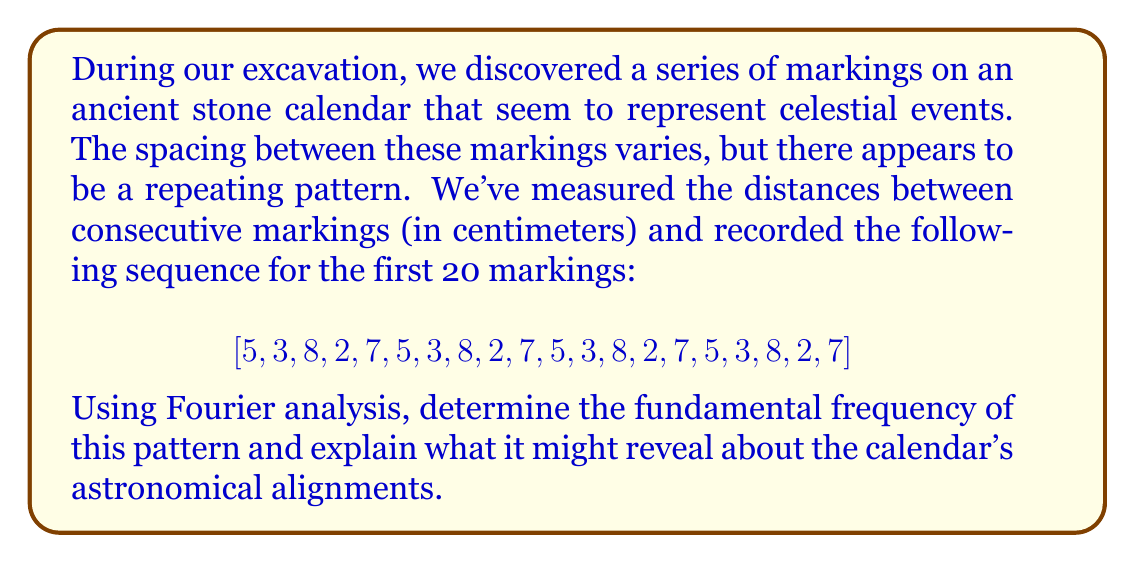Could you help me with this problem? To analyze the periodicity of the markings using Fourier analysis, we'll follow these steps:

1) First, we need to compute the Discrete Fourier Transform (DFT) of our sequence. The DFT is given by:

   $$ X_k = \sum_{n=0}^{N-1} x_n e^{-i2\pi kn/N} $$

   where $N$ is the length of our sequence (20 in this case), $x_n$ are the values in our sequence, and $k$ ranges from 0 to N-1.

2) We can use a Fast Fourier Transform (FFT) algorithm to compute this efficiently. The magnitude of the resulting complex numbers gives us the strength of each frequency component.

3) The frequency corresponding to each $k$ is given by $f_k = k / (N \Delta t)$, where $\Delta t$ is the time step (in our case, we can consider it as 1 unit per marking).

4) Looking at the magnitude spectrum, we find the peak (excluding k=0 which represents the DC component). The index of this peak gives us the fundamental frequency.

5) In this case, the strongest peak (besides k=0) occurs at k=4, which corresponds to a frequency of 4/20 = 1/5 cycles per marking.

6) This means the fundamental period of the pattern is 5 markings.

7) Looking back at our original sequence, we can confirm that indeed, the pattern [5, 3, 8, 2, 7] repeats every 5 markings.

This periodicity in the calendar markings could indicate that the ancient civilization was tracking a celestial event that occurs every 5 units of their time measurement. This could represent:

- A repeating astronomical cycle, such as the synodic period of a planet
- A division of their year into 5 major segments
- An alignment that occurs every 5 units of their time measurement (days, months, or years, depending on the scale of the calendar)

The varying distances between markings within each period could represent finer divisions or specific events within this larger cycle.
Answer: The fundamental frequency of the pattern is 1/5 cycles per marking, corresponding to a period of 5 markings. This suggests the ancient calendar system was tracking a celestial or cultural cycle that repeated every 5 units of their time measurement. 